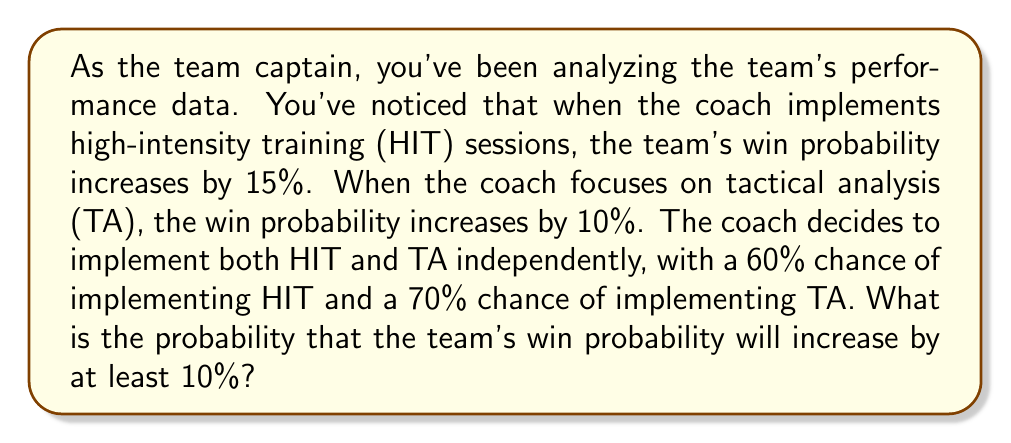Show me your answer to this math problem. Let's approach this step-by-step:

1) Define events:
   H: Coach implements HIT (P(H) = 0.60)
   T: Coach implements TA (P(T) = 0.70)

2) We need to find P(increase ≥ 10%). This can happen in three ways:
   - Only HIT is implemented
   - Only TA is implemented
   - Both HIT and TA are implemented

3) Calculate probabilities:
   P(only HIT) = P(H) * P(not T) = 0.60 * (1 - 0.70) = 0.60 * 0.30 = 0.18
   P(only TA) = P(T) * P(not H) = 0.70 * (1 - 0.60) = 0.70 * 0.40 = 0.28
   P(both) = P(H) * P(T) = 0.60 * 0.70 = 0.42

4) Sum these probabilities:
   P(increase ≥ 10%) = P(only HIT) + P(only TA) + P(both)
                     = 0.18 + 0.28 + 0.42
                     = 0.88

5) Therefore, the probability that the team's win probability will increase by at least 10% is 0.88 or 88%.
Answer: 0.88 